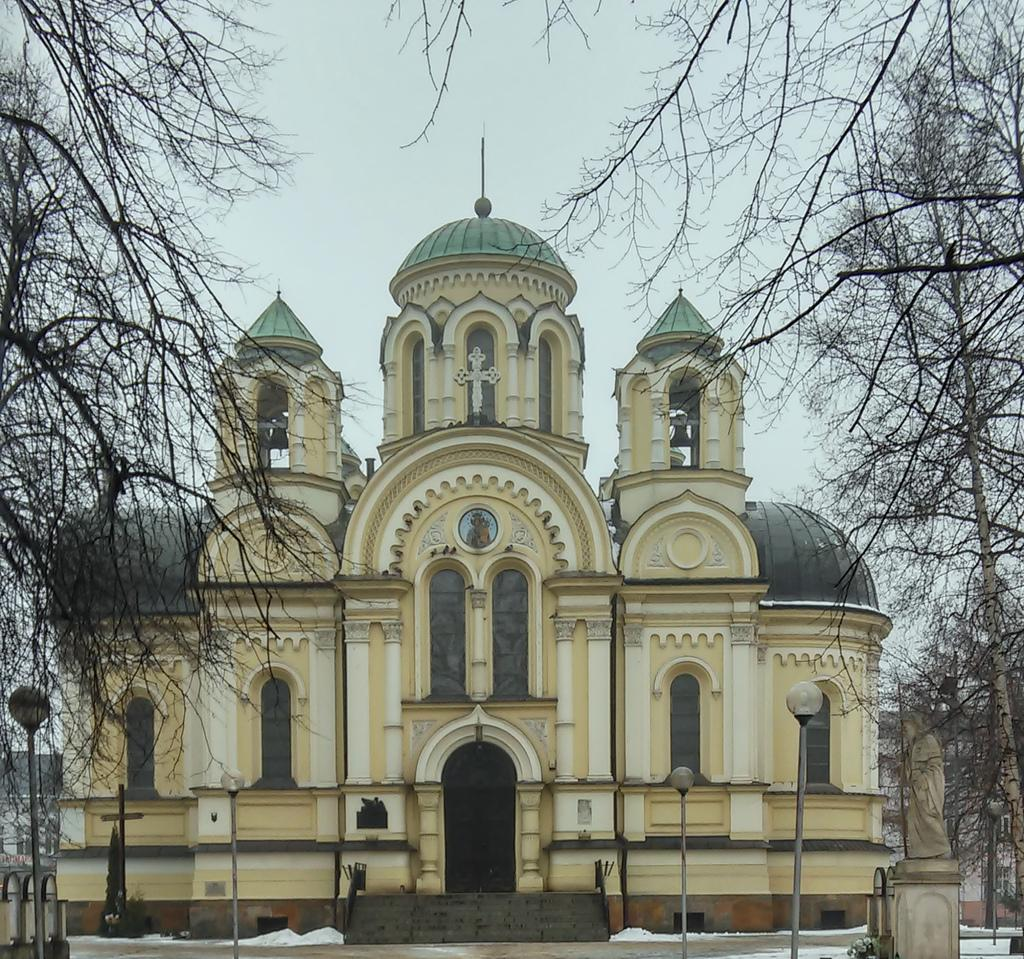What type of building can be seen in the image? There is a cathedral with a cross symbol in the image. What structures are present to provide illumination in the image? Light poles are visible in the image. What type of natural vegetation is present in the image? Trees are present in the image. What weather condition is depicted in the image? Snow is visible in the image. What type of artwork is present in the image? There is a sculpture in the image. What is visible in the background of the image? The sky is visible in the image. Where is the tent located in the image? There is no tent present in the image. What type of footwear is visible on the people in the image? There are no people or shoes visible in the image. 